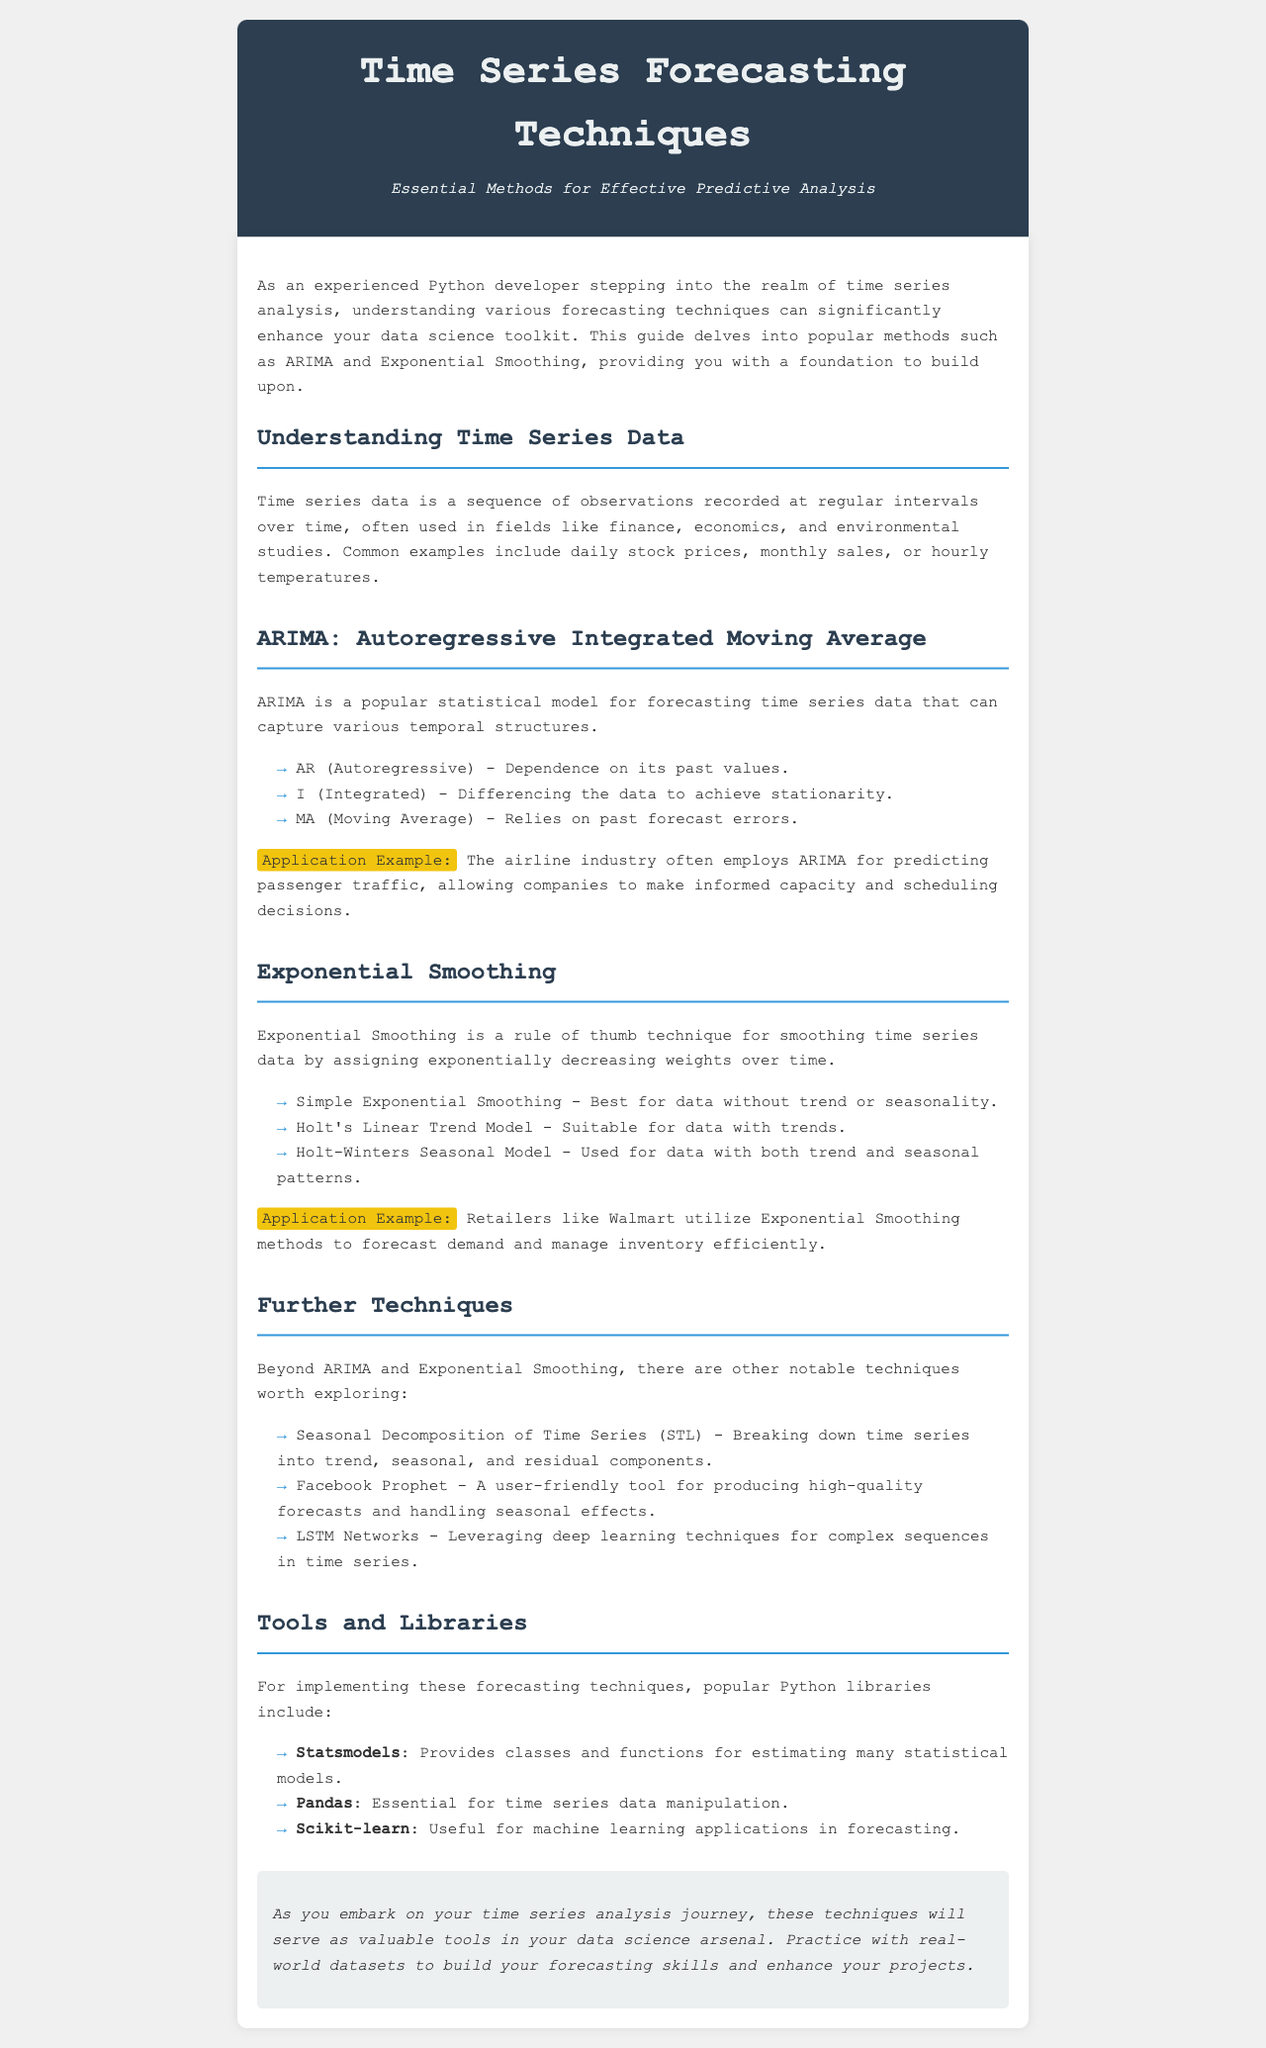What is the title of the newsletter? The title of the newsletter is presented prominently in the header section, indicating the main topic of the document.
Answer: Time Series Forecasting Techniques What forecasting technique is abbreviated as ARIMA? The abbreviation ARIMA stands for Autoregressive Integrated Moving Average, detailed in the section discussing this method.
Answer: Autoregressive Integrated Moving Average What type of data does Exponential Smoothing work best on? The document specifies that Simple Exponential Smoothing is best for data without trend or seasonality.
Answer: Data without trend or seasonality Which industry commonly uses ARIMA for forecasting? An example in the document notes the airline industry, showcasing a practical application of ARIMA.
Answer: Airline industry What is one of the tools mentioned for implementing time series forecasting in Python? The document lists various libraries, highlighting Statsmodels as one of the key tools for statistical modeling.
Answer: Statsmodels Which Exponential Smoothing model is suitable for data with both trend and seasonal patterns? The document identifies Holt-Winters Seasonal Model as the appropriate choice for this scenario.
Answer: Holt-Winters Seasonal Model What does the acronym LSTM stand for in the context of further techniques? The document uses LSTM to refer to a specific method related to deep learning techniques for time series analysis.
Answer: LSTM Networks What is the subtitle of the newsletter? The subtitle gives additional context on the purpose of the document, appearing under the main title to provide more detail.
Answer: Essential Methods for Effective Predictive Analysis 